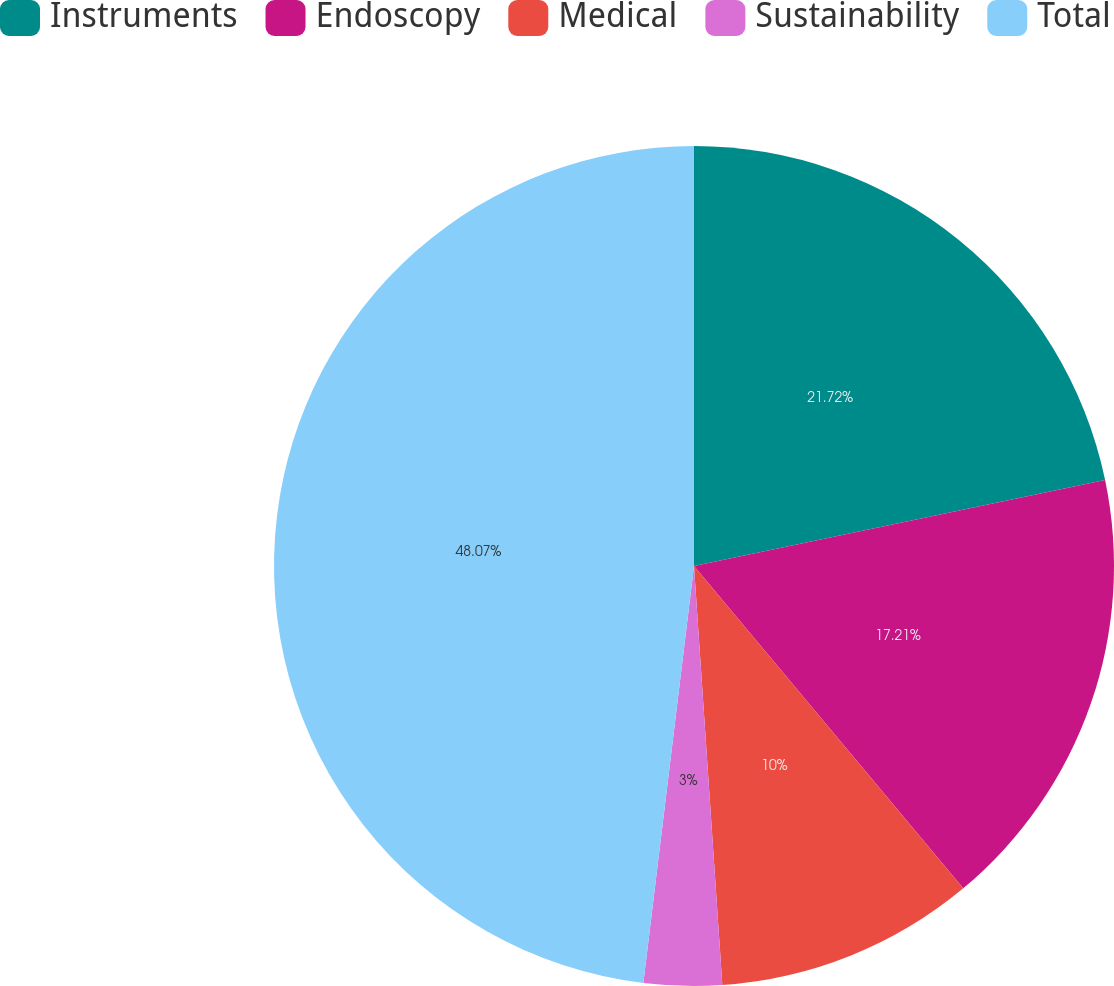Convert chart to OTSL. <chart><loc_0><loc_0><loc_500><loc_500><pie_chart><fcel>Instruments<fcel>Endoscopy<fcel>Medical<fcel>Sustainability<fcel>Total<nl><fcel>21.72%<fcel>17.21%<fcel>10.0%<fcel>3.0%<fcel>48.08%<nl></chart> 